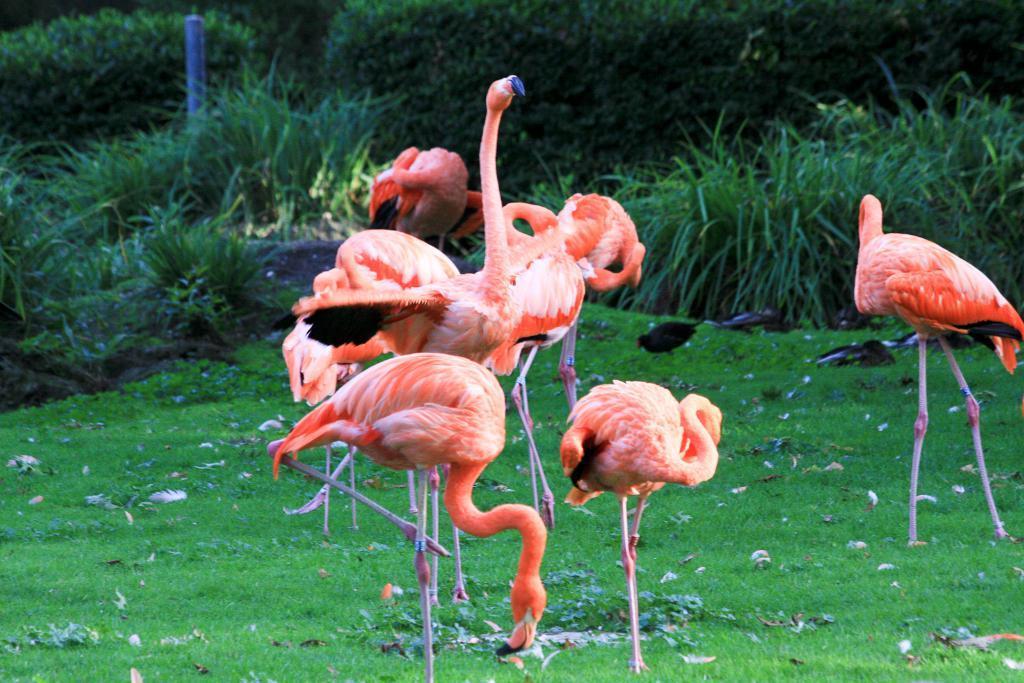Can you describe this image briefly? In this image there are flamingos standing on the grass, and in the background there is a bird, grass, plants. 